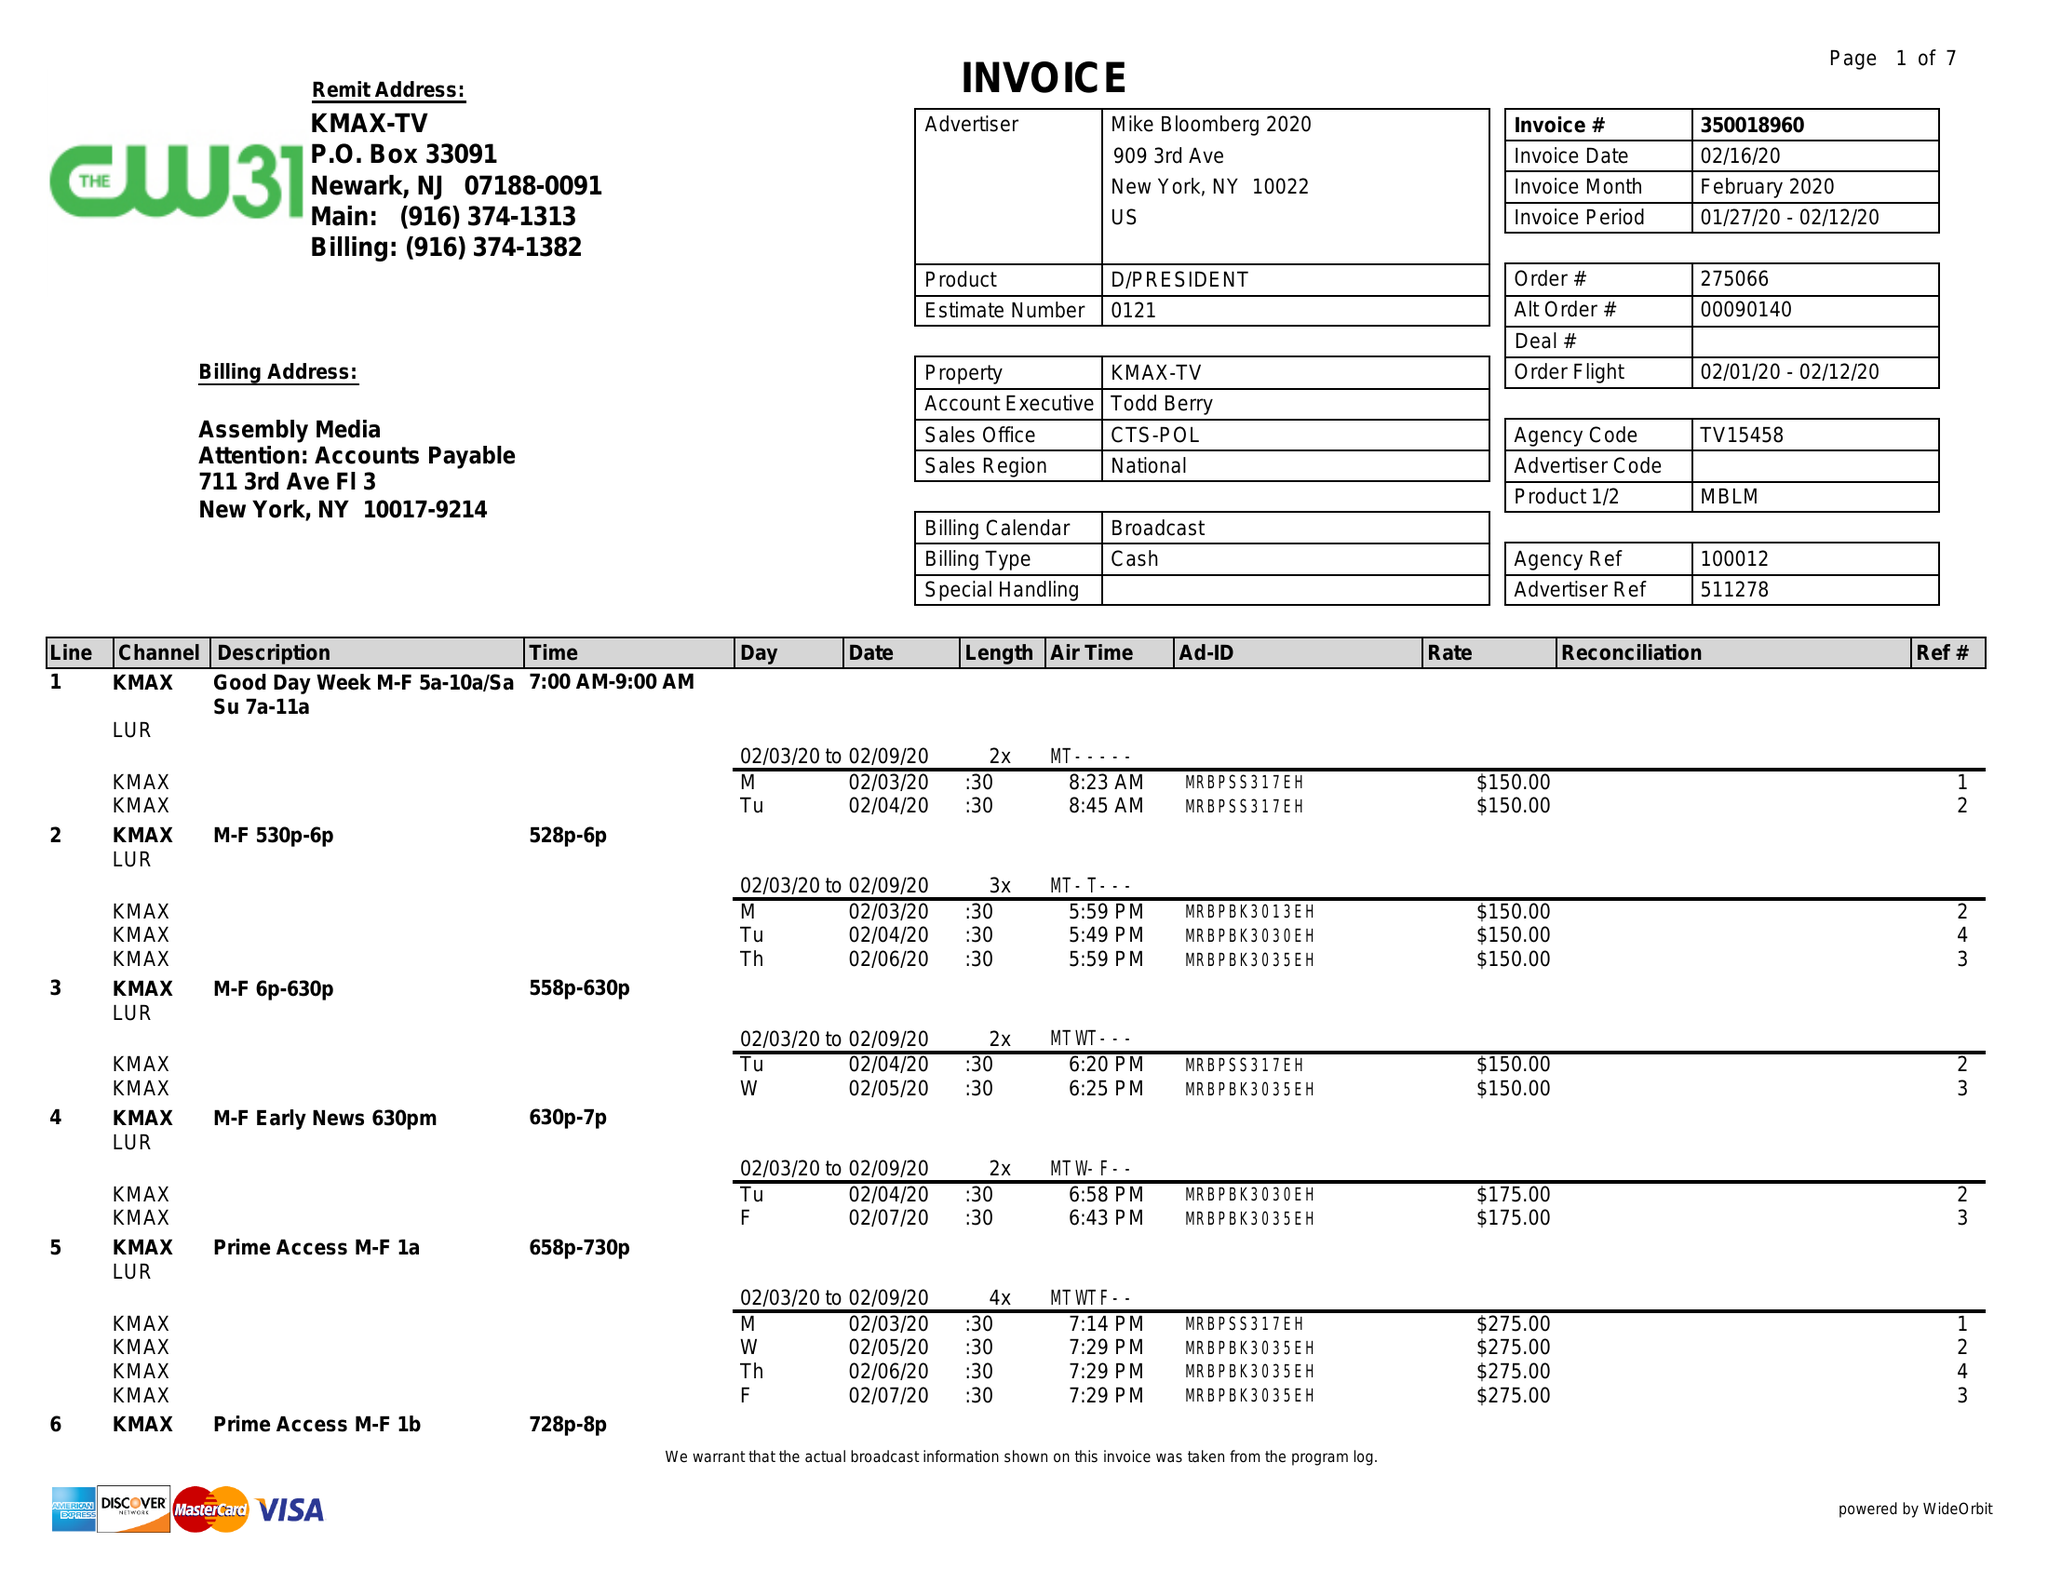What is the value for the flight_from?
Answer the question using a single word or phrase. 02/01/20 